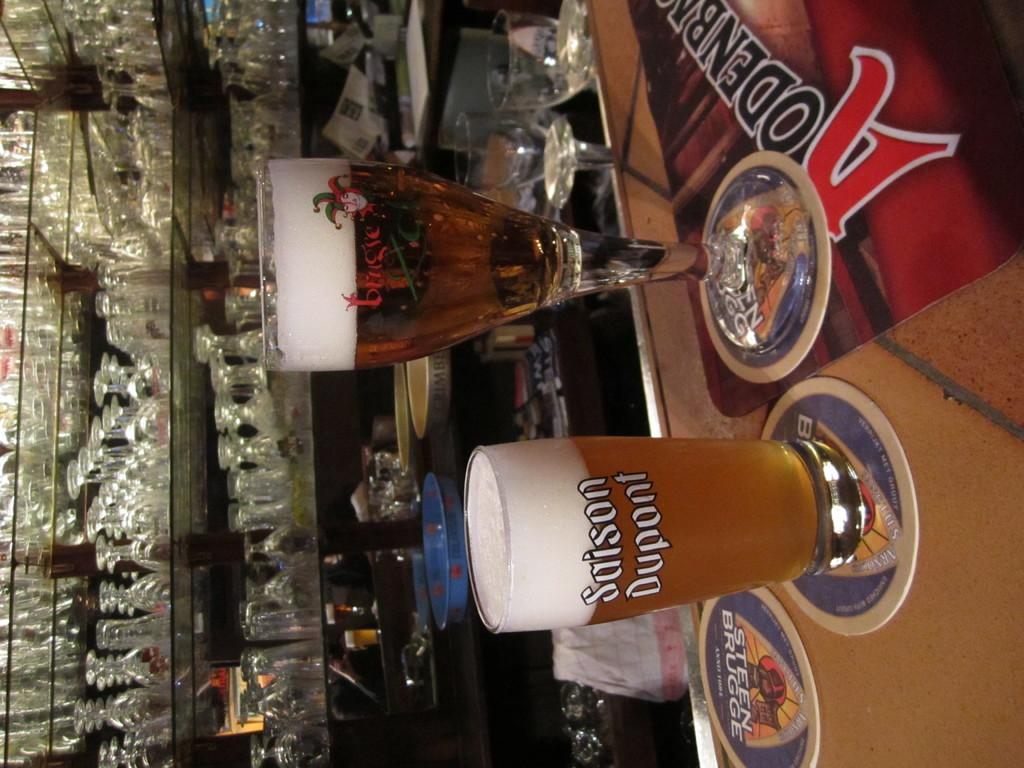<image>
Describe the image concisely. A Saison Dupont glass and a Bruges glass are sitting on a bar. 